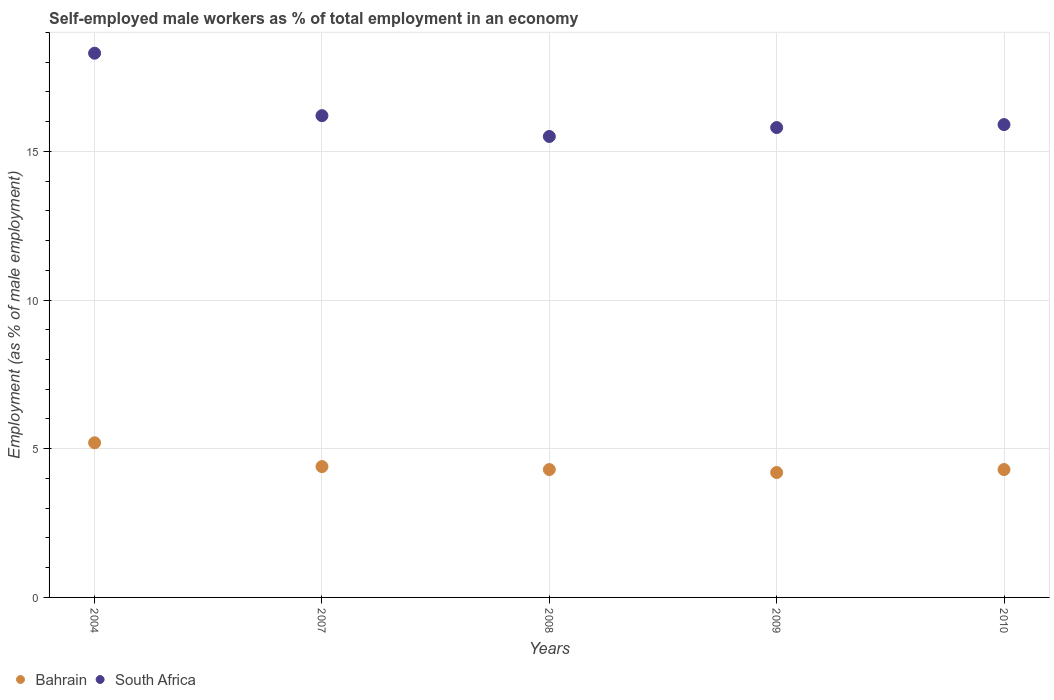How many different coloured dotlines are there?
Give a very brief answer. 2. What is the percentage of self-employed male workers in South Africa in 2004?
Your response must be concise. 18.3. Across all years, what is the maximum percentage of self-employed male workers in Bahrain?
Provide a short and direct response. 5.2. In which year was the percentage of self-employed male workers in Bahrain minimum?
Your response must be concise. 2009. What is the total percentage of self-employed male workers in South Africa in the graph?
Provide a succinct answer. 81.7. What is the difference between the percentage of self-employed male workers in Bahrain in 2004 and that in 2007?
Offer a terse response. 0.8. What is the difference between the percentage of self-employed male workers in Bahrain in 2004 and the percentage of self-employed male workers in South Africa in 2008?
Provide a short and direct response. -10.3. What is the average percentage of self-employed male workers in Bahrain per year?
Offer a terse response. 4.48. In the year 2008, what is the difference between the percentage of self-employed male workers in South Africa and percentage of self-employed male workers in Bahrain?
Offer a terse response. 11.2. What is the ratio of the percentage of self-employed male workers in South Africa in 2008 to that in 2010?
Offer a very short reply. 0.97. Is the percentage of self-employed male workers in South Africa in 2004 less than that in 2009?
Provide a short and direct response. No. What is the difference between the highest and the second highest percentage of self-employed male workers in Bahrain?
Make the answer very short. 0.8. What is the difference between the highest and the lowest percentage of self-employed male workers in Bahrain?
Give a very brief answer. 1. Is the sum of the percentage of self-employed male workers in Bahrain in 2008 and 2010 greater than the maximum percentage of self-employed male workers in South Africa across all years?
Your response must be concise. No. Does the percentage of self-employed male workers in Bahrain monotonically increase over the years?
Provide a succinct answer. No. Is the percentage of self-employed male workers in South Africa strictly greater than the percentage of self-employed male workers in Bahrain over the years?
Your answer should be very brief. Yes. Is the percentage of self-employed male workers in Bahrain strictly less than the percentage of self-employed male workers in South Africa over the years?
Your answer should be compact. Yes. Does the graph contain any zero values?
Your response must be concise. No. How many legend labels are there?
Provide a succinct answer. 2. What is the title of the graph?
Your answer should be very brief. Self-employed male workers as % of total employment in an economy. Does "Netherlands" appear as one of the legend labels in the graph?
Ensure brevity in your answer.  No. What is the label or title of the X-axis?
Ensure brevity in your answer.  Years. What is the label or title of the Y-axis?
Your response must be concise. Employment (as % of male employment). What is the Employment (as % of male employment) of Bahrain in 2004?
Make the answer very short. 5.2. What is the Employment (as % of male employment) in South Africa in 2004?
Offer a very short reply. 18.3. What is the Employment (as % of male employment) in Bahrain in 2007?
Provide a short and direct response. 4.4. What is the Employment (as % of male employment) of South Africa in 2007?
Ensure brevity in your answer.  16.2. What is the Employment (as % of male employment) of Bahrain in 2008?
Provide a short and direct response. 4.3. What is the Employment (as % of male employment) of Bahrain in 2009?
Ensure brevity in your answer.  4.2. What is the Employment (as % of male employment) of South Africa in 2009?
Provide a succinct answer. 15.8. What is the Employment (as % of male employment) of Bahrain in 2010?
Provide a short and direct response. 4.3. What is the Employment (as % of male employment) in South Africa in 2010?
Provide a succinct answer. 15.9. Across all years, what is the maximum Employment (as % of male employment) of Bahrain?
Make the answer very short. 5.2. Across all years, what is the maximum Employment (as % of male employment) of South Africa?
Your answer should be compact. 18.3. Across all years, what is the minimum Employment (as % of male employment) of Bahrain?
Keep it short and to the point. 4.2. Across all years, what is the minimum Employment (as % of male employment) of South Africa?
Provide a succinct answer. 15.5. What is the total Employment (as % of male employment) in Bahrain in the graph?
Keep it short and to the point. 22.4. What is the total Employment (as % of male employment) in South Africa in the graph?
Provide a short and direct response. 81.7. What is the difference between the Employment (as % of male employment) of Bahrain in 2004 and that in 2007?
Keep it short and to the point. 0.8. What is the difference between the Employment (as % of male employment) in South Africa in 2004 and that in 2007?
Keep it short and to the point. 2.1. What is the difference between the Employment (as % of male employment) of South Africa in 2004 and that in 2008?
Your answer should be very brief. 2.8. What is the difference between the Employment (as % of male employment) in Bahrain in 2004 and that in 2009?
Make the answer very short. 1. What is the difference between the Employment (as % of male employment) in South Africa in 2004 and that in 2009?
Offer a very short reply. 2.5. What is the difference between the Employment (as % of male employment) of Bahrain in 2004 and that in 2010?
Provide a short and direct response. 0.9. What is the difference between the Employment (as % of male employment) in South Africa in 2004 and that in 2010?
Provide a short and direct response. 2.4. What is the difference between the Employment (as % of male employment) in Bahrain in 2007 and that in 2008?
Give a very brief answer. 0.1. What is the difference between the Employment (as % of male employment) in South Africa in 2007 and that in 2008?
Your response must be concise. 0.7. What is the difference between the Employment (as % of male employment) of Bahrain in 2007 and that in 2009?
Your response must be concise. 0.2. What is the difference between the Employment (as % of male employment) of South Africa in 2007 and that in 2010?
Ensure brevity in your answer.  0.3. What is the difference between the Employment (as % of male employment) in Bahrain in 2008 and that in 2010?
Offer a very short reply. 0. What is the difference between the Employment (as % of male employment) of South Africa in 2008 and that in 2010?
Give a very brief answer. -0.4. What is the difference between the Employment (as % of male employment) of Bahrain in 2009 and that in 2010?
Offer a very short reply. -0.1. What is the difference between the Employment (as % of male employment) in Bahrain in 2004 and the Employment (as % of male employment) in South Africa in 2007?
Offer a terse response. -11. What is the difference between the Employment (as % of male employment) in Bahrain in 2004 and the Employment (as % of male employment) in South Africa in 2008?
Give a very brief answer. -10.3. What is the difference between the Employment (as % of male employment) in Bahrain in 2007 and the Employment (as % of male employment) in South Africa in 2009?
Give a very brief answer. -11.4. What is the difference between the Employment (as % of male employment) in Bahrain in 2008 and the Employment (as % of male employment) in South Africa in 2009?
Your answer should be very brief. -11.5. What is the difference between the Employment (as % of male employment) in Bahrain in 2009 and the Employment (as % of male employment) in South Africa in 2010?
Ensure brevity in your answer.  -11.7. What is the average Employment (as % of male employment) of Bahrain per year?
Your response must be concise. 4.48. What is the average Employment (as % of male employment) of South Africa per year?
Offer a very short reply. 16.34. In the year 2007, what is the difference between the Employment (as % of male employment) in Bahrain and Employment (as % of male employment) in South Africa?
Provide a short and direct response. -11.8. In the year 2009, what is the difference between the Employment (as % of male employment) in Bahrain and Employment (as % of male employment) in South Africa?
Provide a short and direct response. -11.6. In the year 2010, what is the difference between the Employment (as % of male employment) in Bahrain and Employment (as % of male employment) in South Africa?
Your response must be concise. -11.6. What is the ratio of the Employment (as % of male employment) in Bahrain in 2004 to that in 2007?
Make the answer very short. 1.18. What is the ratio of the Employment (as % of male employment) in South Africa in 2004 to that in 2007?
Ensure brevity in your answer.  1.13. What is the ratio of the Employment (as % of male employment) of Bahrain in 2004 to that in 2008?
Offer a terse response. 1.21. What is the ratio of the Employment (as % of male employment) of South Africa in 2004 to that in 2008?
Make the answer very short. 1.18. What is the ratio of the Employment (as % of male employment) of Bahrain in 2004 to that in 2009?
Keep it short and to the point. 1.24. What is the ratio of the Employment (as % of male employment) in South Africa in 2004 to that in 2009?
Offer a very short reply. 1.16. What is the ratio of the Employment (as % of male employment) in Bahrain in 2004 to that in 2010?
Your response must be concise. 1.21. What is the ratio of the Employment (as % of male employment) in South Africa in 2004 to that in 2010?
Provide a short and direct response. 1.15. What is the ratio of the Employment (as % of male employment) in Bahrain in 2007 to that in 2008?
Your answer should be very brief. 1.02. What is the ratio of the Employment (as % of male employment) of South Africa in 2007 to that in 2008?
Your answer should be compact. 1.05. What is the ratio of the Employment (as % of male employment) in Bahrain in 2007 to that in 2009?
Your answer should be very brief. 1.05. What is the ratio of the Employment (as % of male employment) of South Africa in 2007 to that in 2009?
Your response must be concise. 1.03. What is the ratio of the Employment (as % of male employment) in Bahrain in 2007 to that in 2010?
Give a very brief answer. 1.02. What is the ratio of the Employment (as % of male employment) in South Africa in 2007 to that in 2010?
Keep it short and to the point. 1.02. What is the ratio of the Employment (as % of male employment) in Bahrain in 2008 to that in 2009?
Your answer should be very brief. 1.02. What is the ratio of the Employment (as % of male employment) of South Africa in 2008 to that in 2009?
Keep it short and to the point. 0.98. What is the ratio of the Employment (as % of male employment) in South Africa in 2008 to that in 2010?
Offer a very short reply. 0.97. What is the ratio of the Employment (as % of male employment) of Bahrain in 2009 to that in 2010?
Ensure brevity in your answer.  0.98. What is the ratio of the Employment (as % of male employment) of South Africa in 2009 to that in 2010?
Give a very brief answer. 0.99. What is the difference between the highest and the second highest Employment (as % of male employment) in South Africa?
Your answer should be very brief. 2.1. What is the difference between the highest and the lowest Employment (as % of male employment) of Bahrain?
Your answer should be very brief. 1. What is the difference between the highest and the lowest Employment (as % of male employment) of South Africa?
Provide a short and direct response. 2.8. 